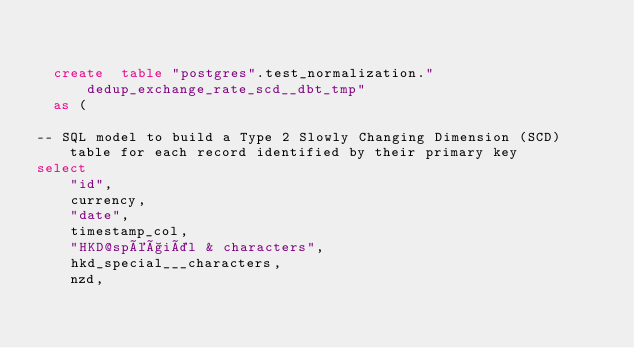Convert code to text. <code><loc_0><loc_0><loc_500><loc_500><_SQL_>

  create  table "postgres".test_normalization."dedup_exchange_rate_scd__dbt_tmp"
  as (
    
-- SQL model to build a Type 2 Slowly Changing Dimension (SCD) table for each record identified by their primary key
select
    "id",
    currency,
    "date",
    timestamp_col,
    "HKD@spéçiäl & characters",
    hkd_special___characters,
    nzd,</code> 